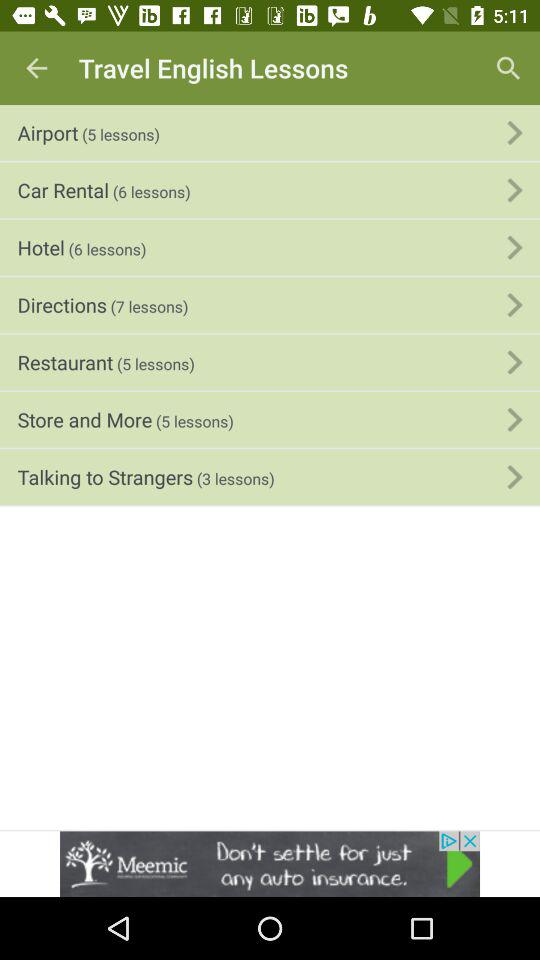How user-friendly do you think this app interface is for non-native English speakers? This application interface appears to be user-friendly for non-native speakers, with clear headings and descriptors. The number of lessons is indicated alongside each topic, making it easy to identify the scope of each section. Accompanying icons or visual representations of each category, were they present, could further enhance the intuitiveness of the platform. 